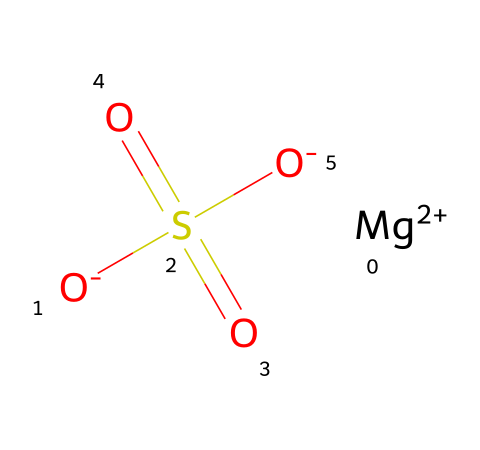What ions are present in magnesium sulfate? This chemical contains magnesium and sulfate ions. The presence of "[Mg+2]" indicates magnesium as a cation, and "S(=O)(=O)[O-]" showing the sulfate anion with its characteristic sulfur and oxygen arrangement.
Answer: magnesium and sulfate How many oxygen atoms are in the chemical structure? In the sulfate ion "S(=O)(=O)[O-]", there are three oxygen atoms: two double-bonded to sulfur and one single-bonded to sulfur, totaling three oxygen atoms.
Answer: three What is the charge of the magnesium ion? The notation "[Mg+2]" indicates that the magnesium ion carries a charge of +2.
Answer: +2 What is the molecular formula of magnesium sulfate? From the SMILES representation, the formula can be derived: one magnesium (Mg), one sulfur (S), and four oxygen (O) atoms, leading to the formula MgSO4.
Answer: MgSO4 What role does magnesium sulfate play in biological systems? Magnesium sulfate acts as an electrolyte in biological systems, helping to regulate various physiological functions such as muscle and nerve function.
Answer: electrolyte How does the structure of magnesium sulfate contribute to its solubility in water? The ionic nature of magnesium sulfate allows the positive magnesium ion to attract water molecules, while the sulfate ion's negative charge also interacts favorably with water, enhancing solubility.
Answer: ionic nature 